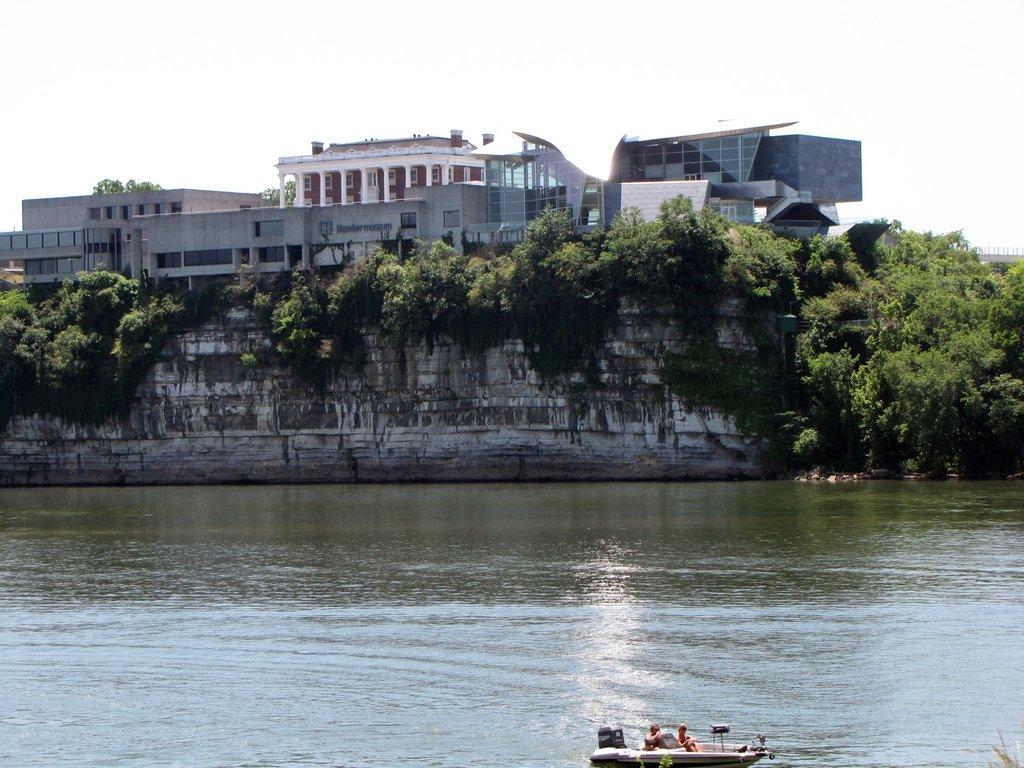Can you describe this image briefly? In this image there is a boat on the water, trees, houses, and in the background there is sky. 